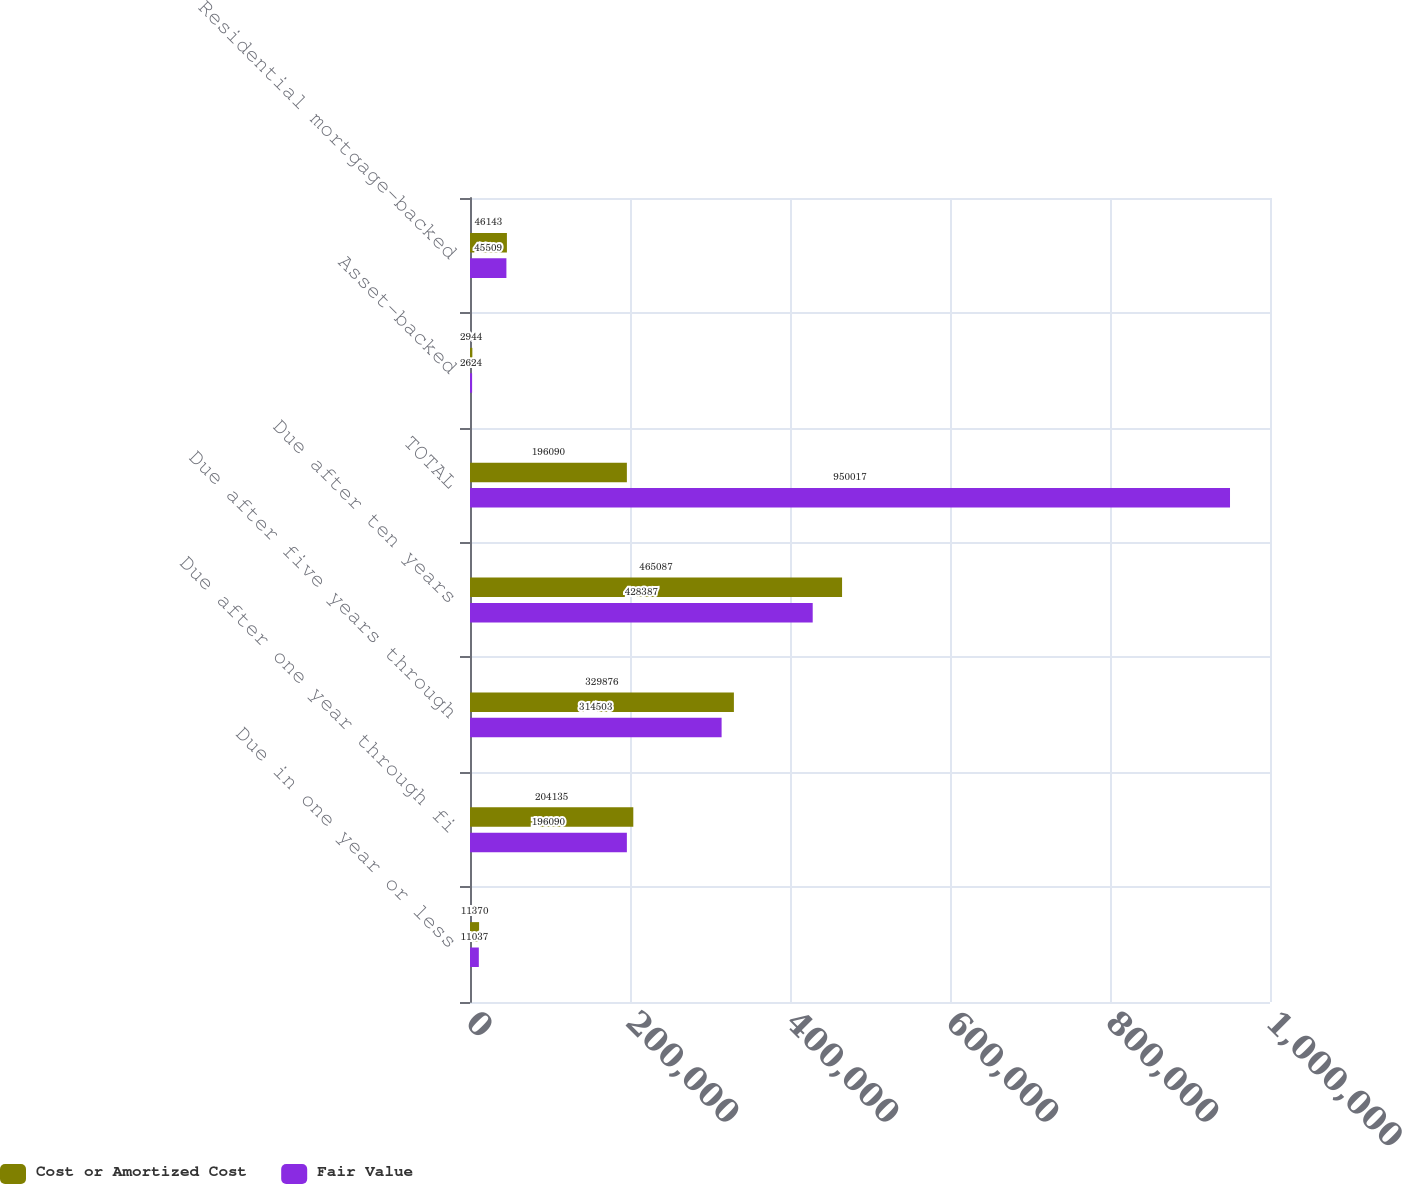Convert chart. <chart><loc_0><loc_0><loc_500><loc_500><stacked_bar_chart><ecel><fcel>Due in one year or less<fcel>Due after one year through fi<fcel>Due after five years through<fcel>Due after ten years<fcel>TOTAL<fcel>Asset-backed<fcel>Residential mortgage-backed<nl><fcel>Cost or Amortized Cost<fcel>11370<fcel>204135<fcel>329876<fcel>465087<fcel>196090<fcel>2944<fcel>46143<nl><fcel>Fair Value<fcel>11037<fcel>196090<fcel>314503<fcel>428387<fcel>950017<fcel>2624<fcel>45509<nl></chart> 